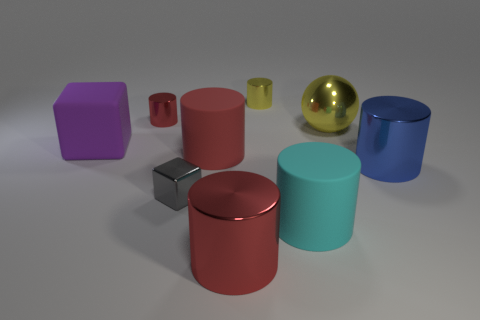Subtract all blue cubes. How many red cylinders are left? 3 Subtract all cyan matte cylinders. How many cylinders are left? 5 Subtract all cyan cylinders. How many cylinders are left? 5 Subtract all brown cylinders. Subtract all brown spheres. How many cylinders are left? 6 Subtract all cylinders. How many objects are left? 3 Subtract 0 blue balls. How many objects are left? 9 Subtract all big rubber objects. Subtract all red shiny cylinders. How many objects are left? 4 Add 3 large things. How many large things are left? 9 Add 2 red metallic things. How many red metallic things exist? 4 